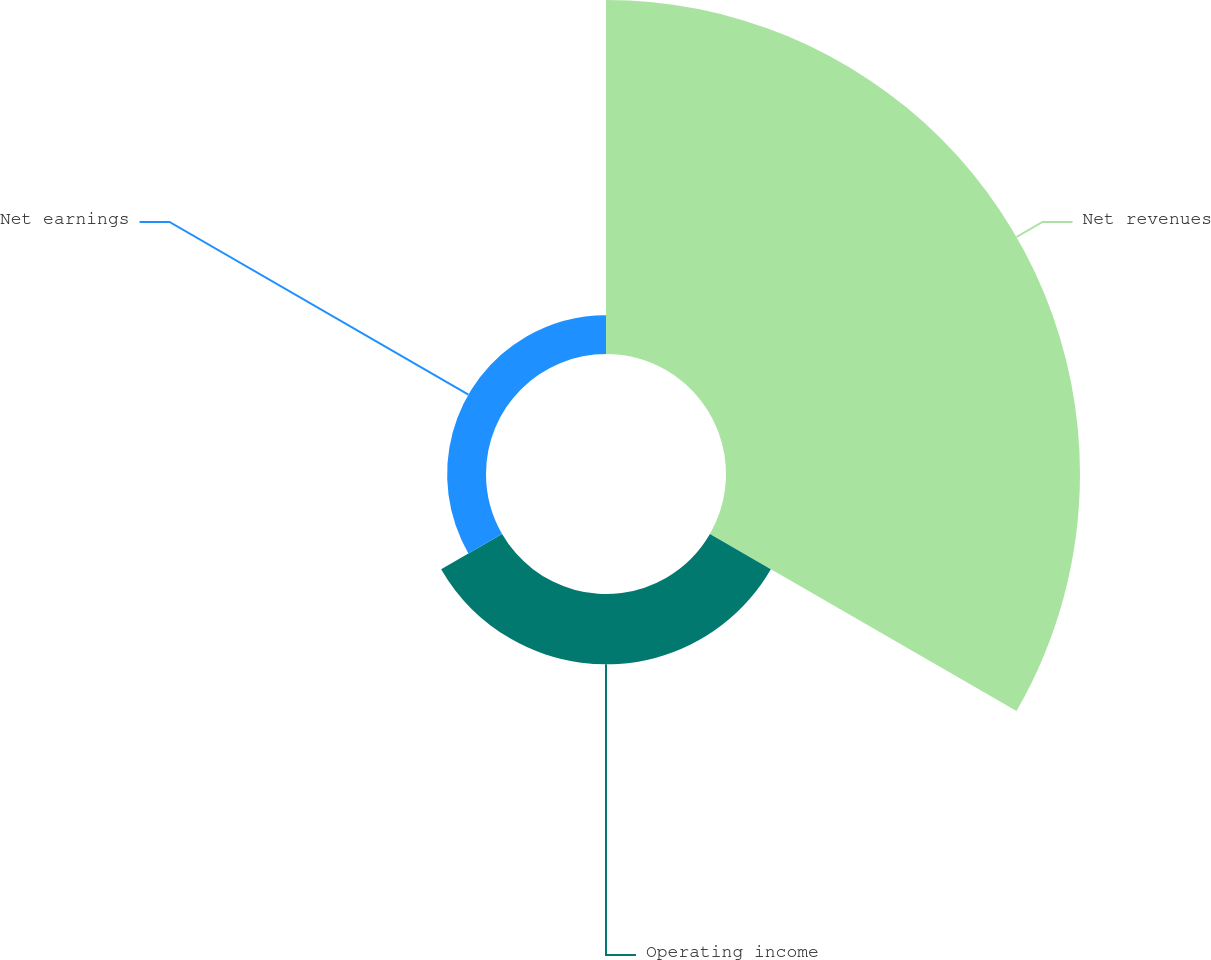<chart> <loc_0><loc_0><loc_500><loc_500><pie_chart><fcel>Net revenues<fcel>Operating income<fcel>Net earnings<nl><fcel>76.42%<fcel>15.19%<fcel>8.39%<nl></chart> 